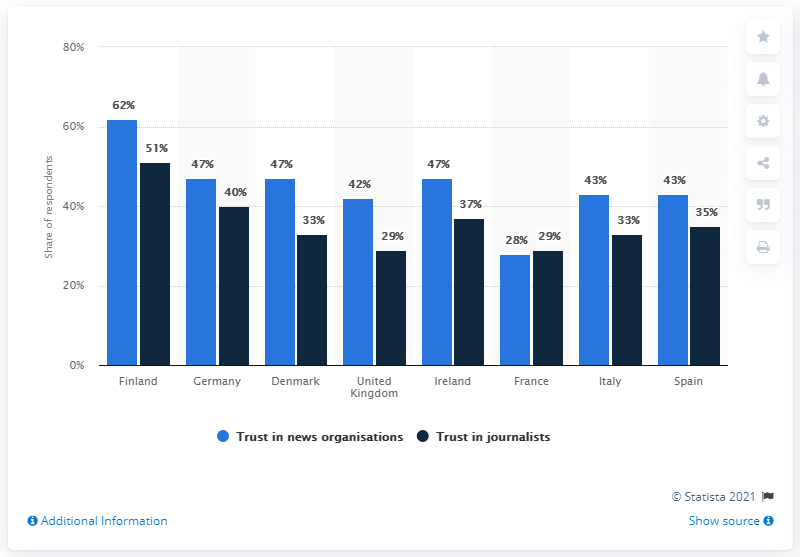Look at Finland data and find how many percentage respondents have Trust in Journalists ?
 51 